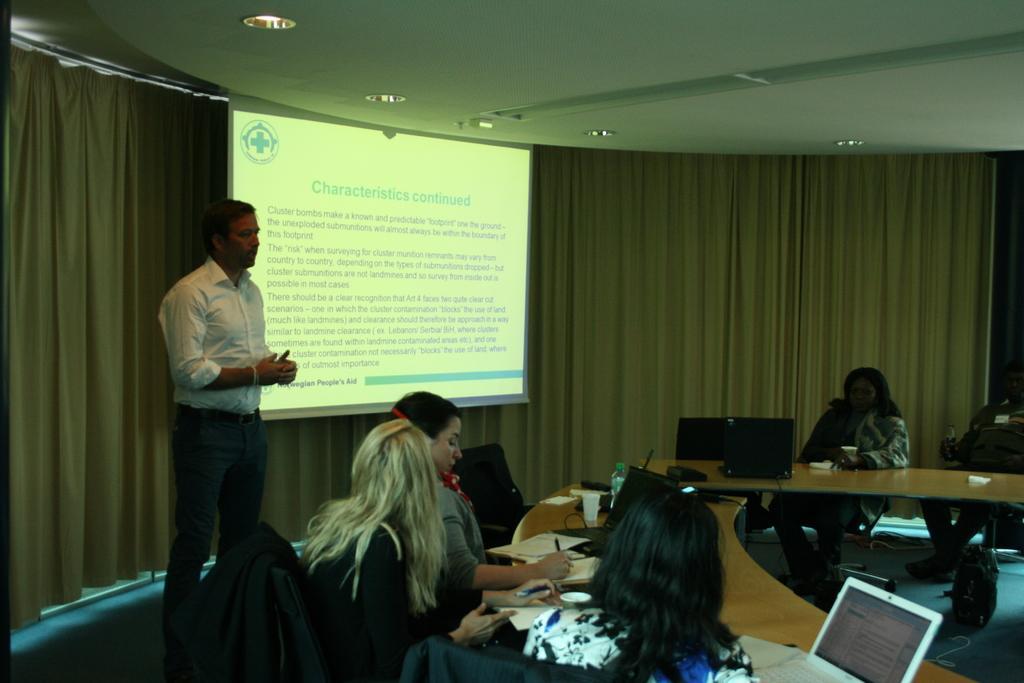In one or two sentences, can you explain what this image depicts? The image is taken in the room. In the center of the room there is a man standing and talking before him there are people sitting around the tables. There are laptops, wires, bottles, glasses, papers and pen placed on the table. In the background there is a curtain and a screen. At the top there are lights. 